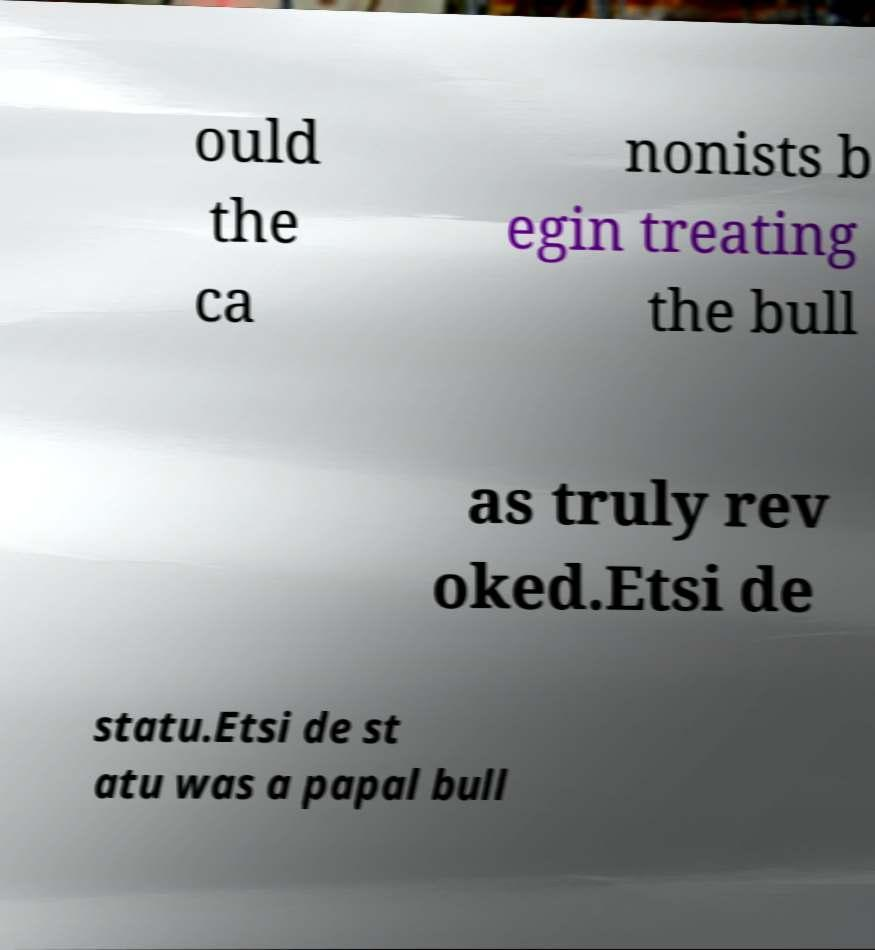For documentation purposes, I need the text within this image transcribed. Could you provide that? ould the ca nonists b egin treating the bull as truly rev oked.Etsi de statu.Etsi de st atu was a papal bull 